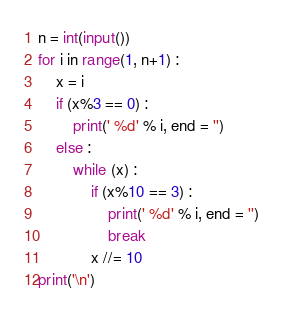Convert code to text. <code><loc_0><loc_0><loc_500><loc_500><_Python_>n = int(input())
for i in range(1, n+1) :
    x = i
    if (x%3 == 0) :
        print(' %d' % i, end = '')
    else :
        while (x) :
            if (x%10 == 3) :
                print(' %d' % i, end = '')
                break
            x //= 10
print('\n')
</code> 